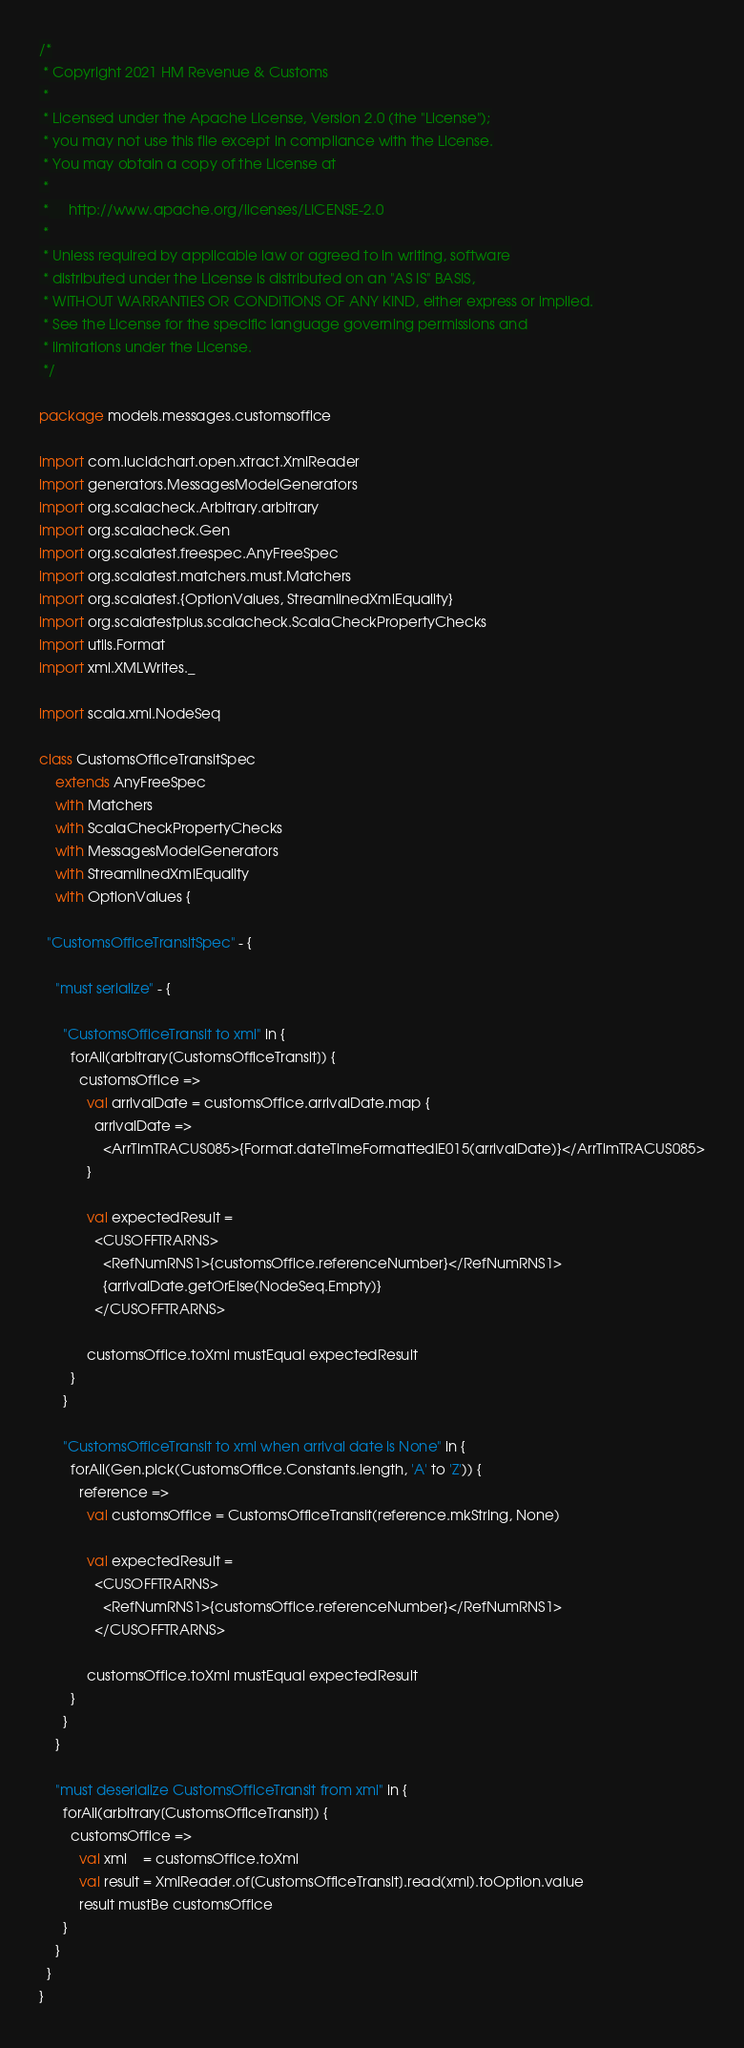Convert code to text. <code><loc_0><loc_0><loc_500><loc_500><_Scala_>/*
 * Copyright 2021 HM Revenue & Customs
 *
 * Licensed under the Apache License, Version 2.0 (the "License");
 * you may not use this file except in compliance with the License.
 * You may obtain a copy of the License at
 *
 *     http://www.apache.org/licenses/LICENSE-2.0
 *
 * Unless required by applicable law or agreed to in writing, software
 * distributed under the License is distributed on an "AS IS" BASIS,
 * WITHOUT WARRANTIES OR CONDITIONS OF ANY KIND, either express or implied.
 * See the License for the specific language governing permissions and
 * limitations under the License.
 */

package models.messages.customsoffice

import com.lucidchart.open.xtract.XmlReader
import generators.MessagesModelGenerators
import org.scalacheck.Arbitrary.arbitrary
import org.scalacheck.Gen
import org.scalatest.freespec.AnyFreeSpec
import org.scalatest.matchers.must.Matchers
import org.scalatest.{OptionValues, StreamlinedXmlEquality}
import org.scalatestplus.scalacheck.ScalaCheckPropertyChecks
import utils.Format
import xml.XMLWrites._

import scala.xml.NodeSeq

class CustomsOfficeTransitSpec
    extends AnyFreeSpec
    with Matchers
    with ScalaCheckPropertyChecks
    with MessagesModelGenerators
    with StreamlinedXmlEquality
    with OptionValues {

  "CustomsOfficeTransitSpec" - {

    "must serialize" - {

      "CustomsOfficeTransit to xml" in {
        forAll(arbitrary[CustomsOfficeTransit]) {
          customsOffice =>
            val arrivalDate = customsOffice.arrivalDate.map {
              arrivalDate =>
                <ArrTimTRACUS085>{Format.dateTimeFormattedIE015(arrivalDate)}</ArrTimTRACUS085>
            }

            val expectedResult =
              <CUSOFFTRARNS>
                <RefNumRNS1>{customsOffice.referenceNumber}</RefNumRNS1>
                {arrivalDate.getOrElse(NodeSeq.Empty)}
              </CUSOFFTRARNS>

            customsOffice.toXml mustEqual expectedResult
        }
      }

      "CustomsOfficeTransit to xml when arrival date is None" in {
        forAll(Gen.pick(CustomsOffice.Constants.length, 'A' to 'Z')) {
          reference =>
            val customsOffice = CustomsOfficeTransit(reference.mkString, None)

            val expectedResult =
              <CUSOFFTRARNS>
                <RefNumRNS1>{customsOffice.referenceNumber}</RefNumRNS1>
              </CUSOFFTRARNS>

            customsOffice.toXml mustEqual expectedResult
        }
      }
    }

    "must deserialize CustomsOfficeTransit from xml" in {
      forAll(arbitrary[CustomsOfficeTransit]) {
        customsOffice =>
          val xml    = customsOffice.toXml
          val result = XmlReader.of[CustomsOfficeTransit].read(xml).toOption.value
          result mustBe customsOffice
      }
    }
  }
}
</code> 